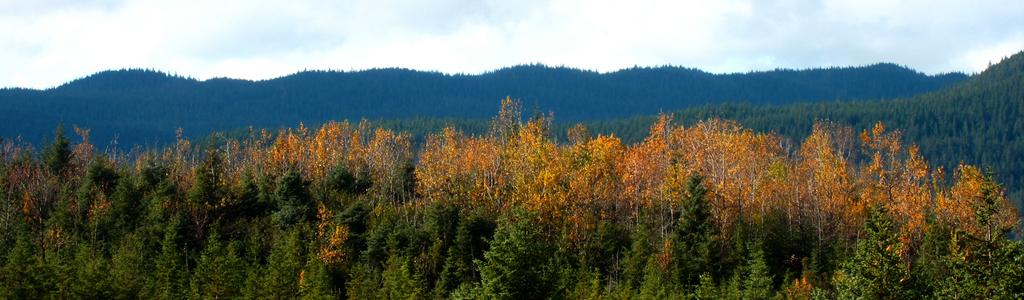What type of living organisms can be seen in the image? Plants and trees are visible in the image. What color are the trees in the image? The trees are yellow in color. What can be seen in the background of the image? Hills and the sky are visible in the background of the image. What is the condition of the sky in the image? Clouds are present in the sky. What type of hole can be seen in the image? There is no hole present in the image. How does the image express hate towards a particular subject? The image does not express hate towards any subject; it simply depicts plants, trees, hills, and the sky. 